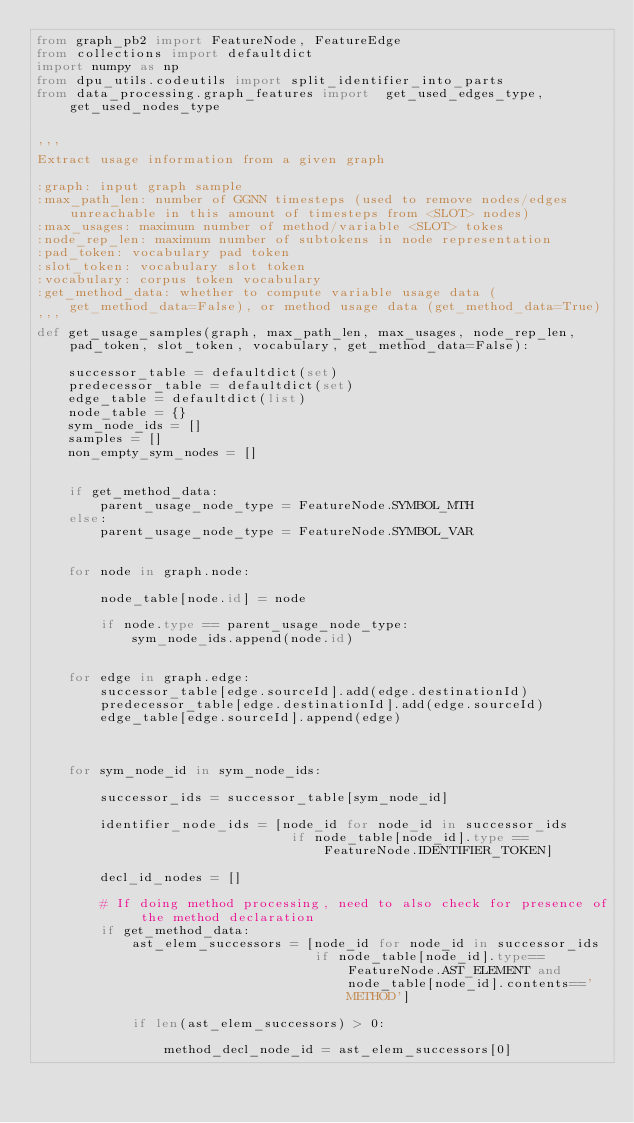<code> <loc_0><loc_0><loc_500><loc_500><_Python_>from graph_pb2 import FeatureNode, FeatureEdge
from collections import defaultdict
import numpy as np
from dpu_utils.codeutils import split_identifier_into_parts
from data_processing.graph_features import  get_used_edges_type, get_used_nodes_type


'''
Extract usage information from a given graph

:graph: input graph sample
:max_path_len: number of GGNN timesteps (used to remove nodes/edges unreachable in this amount of timesteps from <SLOT> nodes)
:max_usages: maximum number of method/variable <SLOT> tokes
:node_rep_len: maximum number of subtokens in node representation
:pad_token: vocabulary pad token
:slot_token: vocabulary slot token
:vocabulary: corpus token vocabulary
:get_method_data: whether to compute variable usage data (get_method_data=False), or method usage data (get_method_data=True)
'''
def get_usage_samples(graph, max_path_len, max_usages, node_rep_len, pad_token, slot_token, vocabulary, get_method_data=False):

    successor_table = defaultdict(set)
    predecessor_table = defaultdict(set)
    edge_table = defaultdict(list)
    node_table = {}
    sym_node_ids = []
    samples = []
    non_empty_sym_nodes = []


    if get_method_data:
        parent_usage_node_type = FeatureNode.SYMBOL_MTH
    else:
        parent_usage_node_type = FeatureNode.SYMBOL_VAR


    for node in graph.node:

        node_table[node.id] = node

        if node.type == parent_usage_node_type:
            sym_node_ids.append(node.id)


    for edge in graph.edge:
        successor_table[edge.sourceId].add(edge.destinationId)
        predecessor_table[edge.destinationId].add(edge.sourceId)
        edge_table[edge.sourceId].append(edge)



    for sym_node_id in sym_node_ids:

        successor_ids = successor_table[sym_node_id]

        identifier_node_ids = [node_id for node_id in successor_ids
                                if node_table[node_id].type == FeatureNode.IDENTIFIER_TOKEN]

        decl_id_nodes = []

        # If doing method processing, need to also check for presence of the method declaration
        if get_method_data:
            ast_elem_successors = [node_id for node_id in successor_ids
                                   if node_table[node_id].type==FeatureNode.AST_ELEMENT and node_table[node_id].contents=='METHOD']

            if len(ast_elem_successors) > 0:

                method_decl_node_id = ast_elem_successors[0]
</code> 